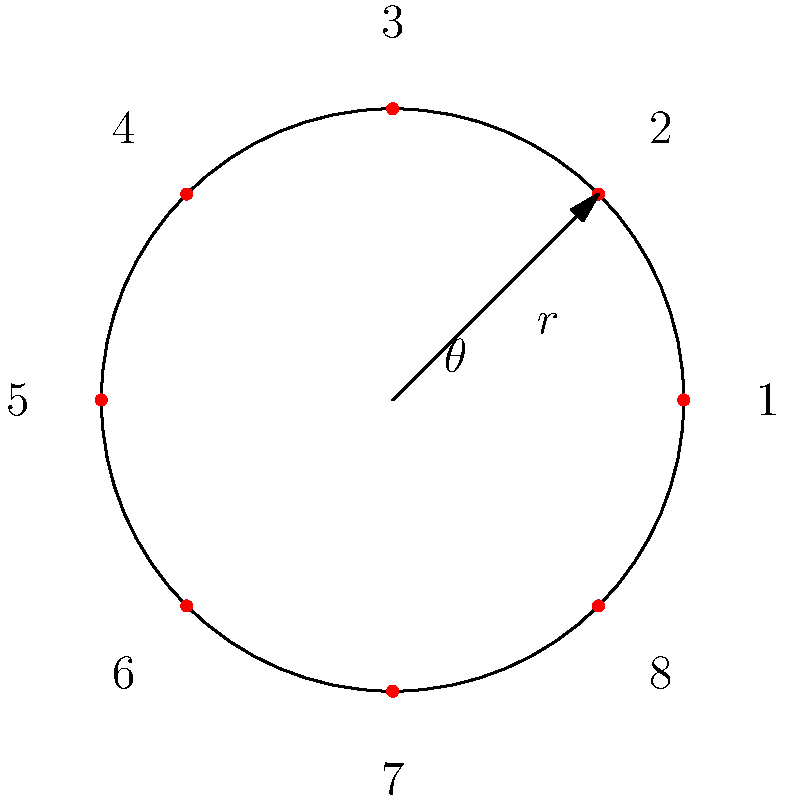As the floor manager of a casino, you're tasked with arranging an 8-player circular poker table. Using polar coordinates, if player 1 is seated at $(r, 0°)$ and the players are numbered clockwise, at what angle $\theta$ (in degrees) would player 4 be seated? To solve this problem, let's follow these steps:

1) In a circular arrangement, the players are evenly distributed around the circle.

2) The total angle of a circle is 360°.

3) With 8 players, each player occupies 360° ÷ 8 = 45° of the circle.

4) Player 1 is at 0°, so we can determine the positions of the other players:
   - Player 2: 45°
   - Player 3: 90°
   - Player 4: 135°
   - Player 5: 180°
   - Player 6: 225°
   - Player 7: 270°
   - Player 8: 315°

5) Therefore, player 4 is seated at an angle of 135°.

This arrangement ensures equal spacing between players, promoting fair play and easy interaction, which aligns with creating a fun and engaging environment for both dealers and players.
Answer: 135° 